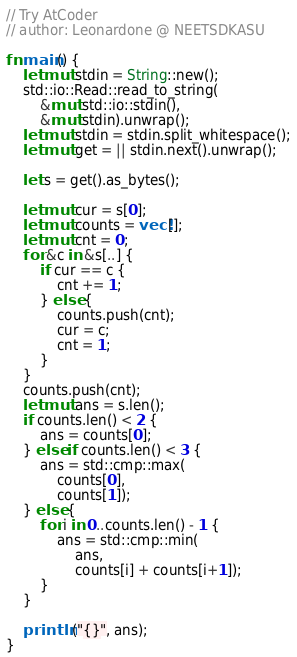<code> <loc_0><loc_0><loc_500><loc_500><_Rust_>// Try AtCoder
// author: Leonardone @ NEETSDKASU

fn main() {
	let mut stdin = String::new();
    std::io::Read::read_to_string(
    	&mut std::io::stdin(),
        &mut stdin).unwrap();
	let mut stdin = stdin.split_whitespace();
    let mut get = || stdin.next().unwrap();
	
    let s = get().as_bytes();
    
    let mut cur = s[0];
    let mut counts = vec![];
    let mut cnt = 0;
    for &c in &s[..] {
    	if cur == c {
        	cnt += 1;
        } else {
        	counts.push(cnt);
            cur = c;
            cnt = 1;
        }
    }
    counts.push(cnt);
    let mut ans = s.len();
    if counts.len() < 2 {
    	ans = counts[0];
    } else if counts.len() < 3 {
	    ans = std::cmp::max(
        	counts[0],
            counts[1]);
    } else {
    	for i in 0..counts.len() - 1 {
        	ans = std::cmp::min(
            	ans,
                counts[i] + counts[i+1]);
        }
    }
    
    println!("{}", ans);
}
</code> 